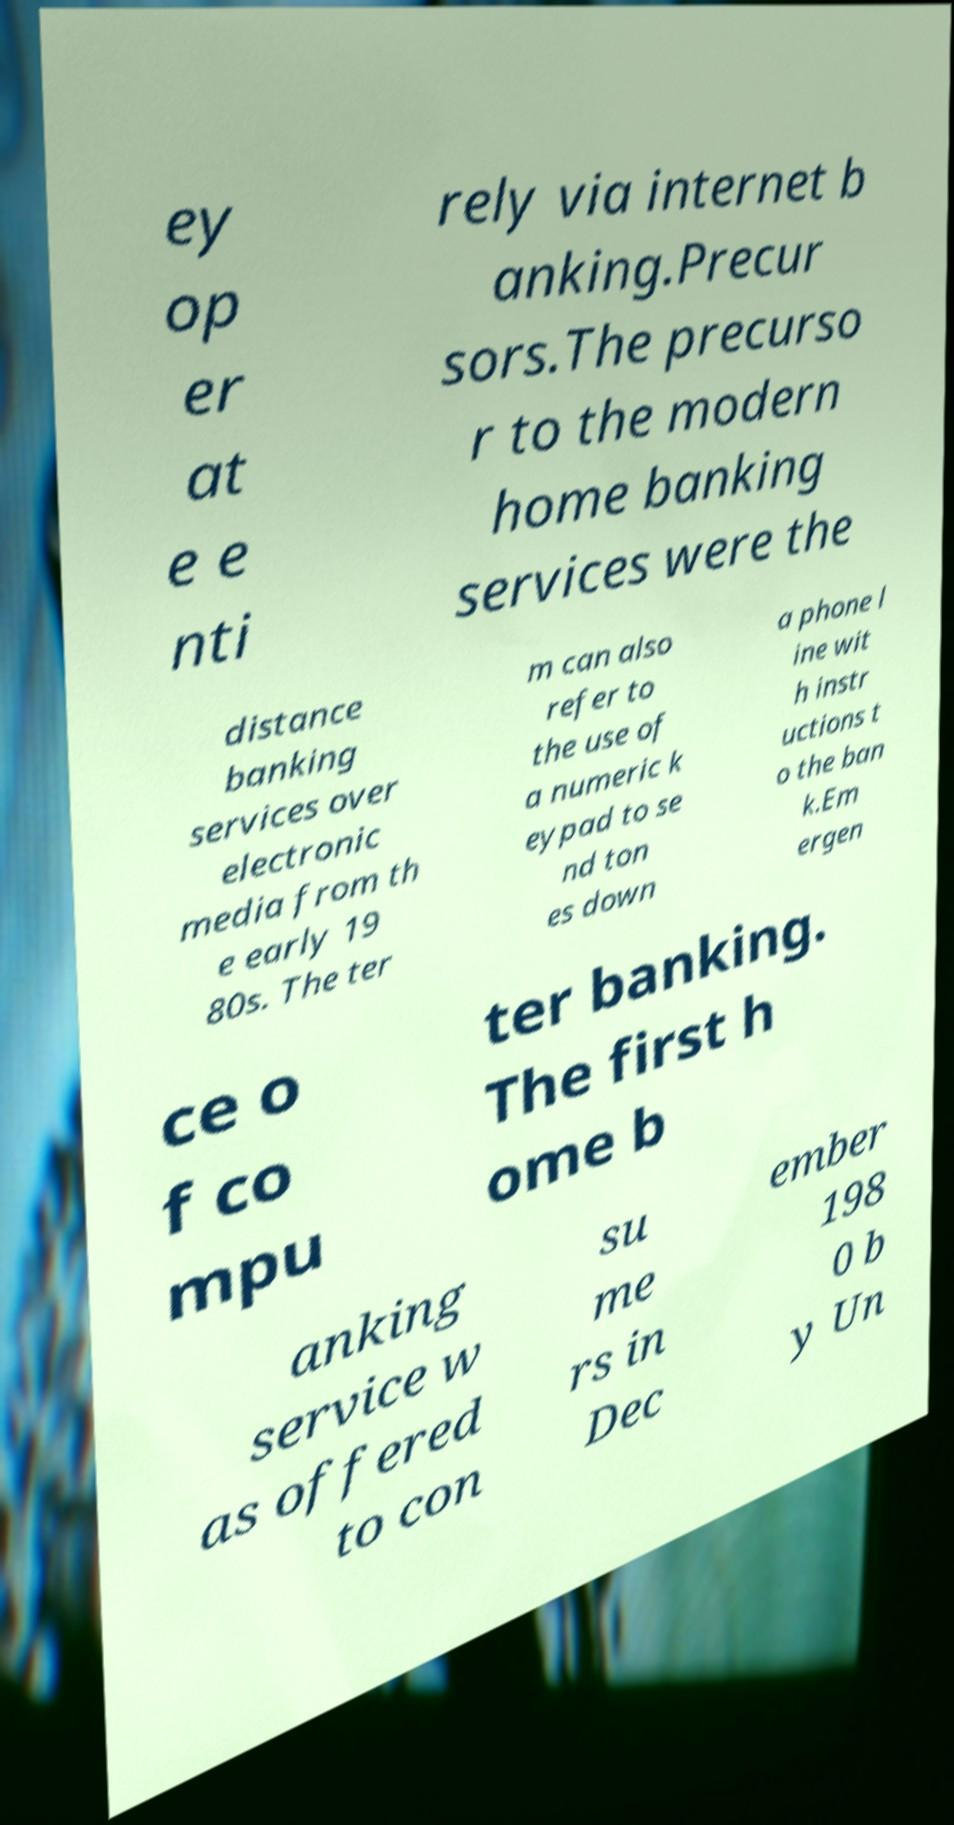I need the written content from this picture converted into text. Can you do that? ey op er at e e nti rely via internet b anking.Precur sors.The precurso r to the modern home banking services were the distance banking services over electronic media from th e early 19 80s. The ter m can also refer to the use of a numeric k eypad to se nd ton es down a phone l ine wit h instr uctions t o the ban k.Em ergen ce o f co mpu ter banking. The first h ome b anking service w as offered to con su me rs in Dec ember 198 0 b y Un 